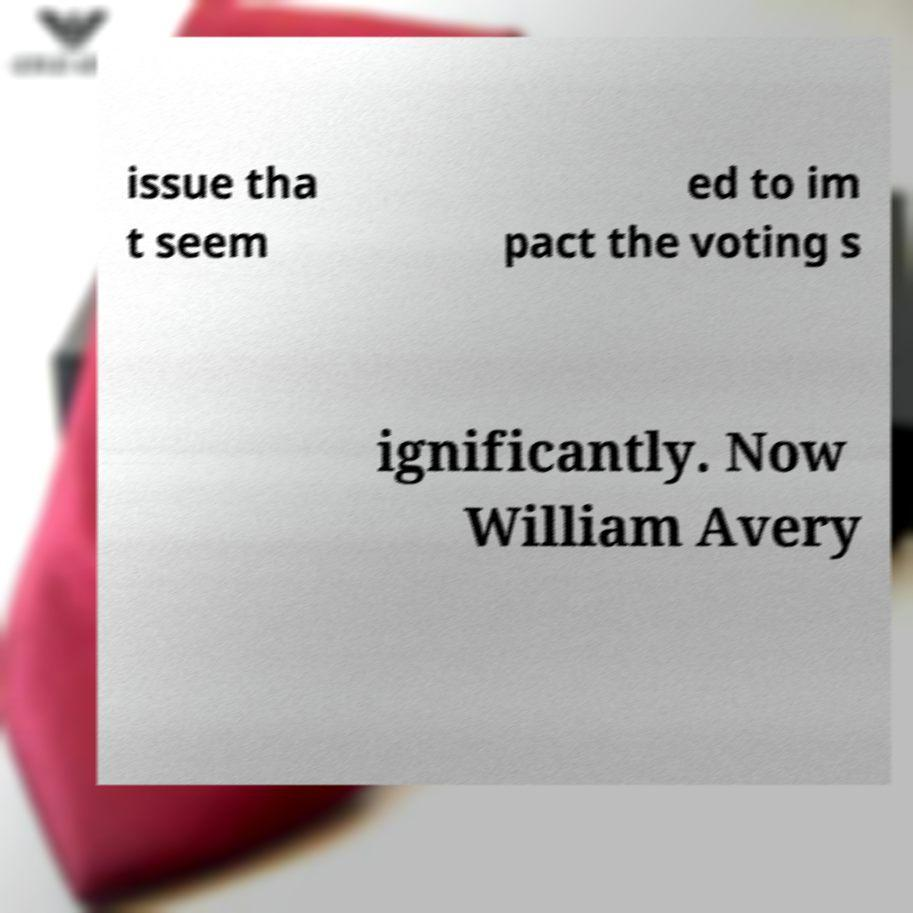What messages or text are displayed in this image? I need them in a readable, typed format. issue tha t seem ed to im pact the voting s ignificantly. Now William Avery 